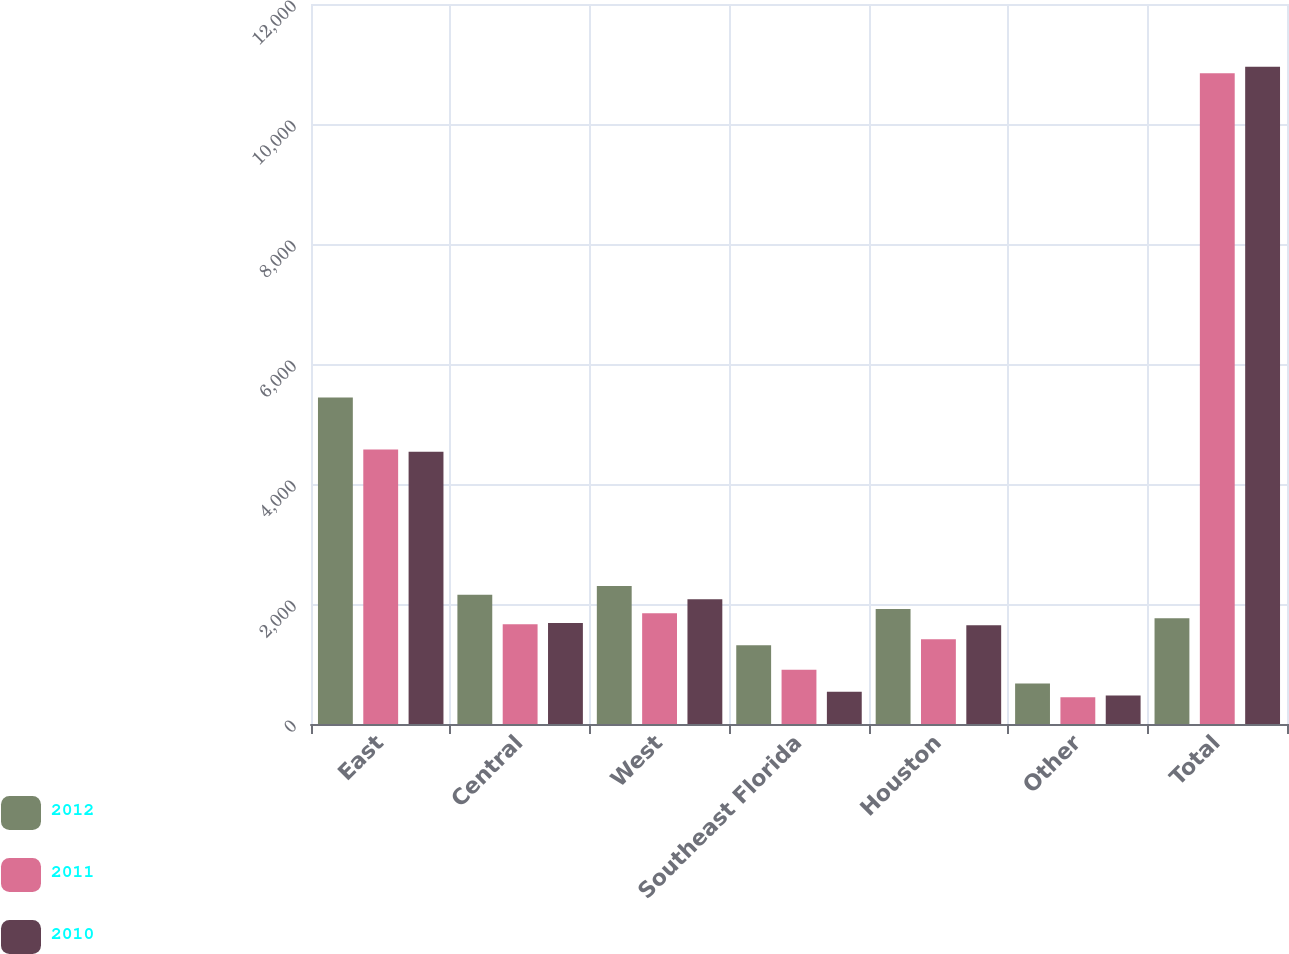<chart> <loc_0><loc_0><loc_500><loc_500><stacked_bar_chart><ecel><fcel>East<fcel>Central<fcel>West<fcel>Southeast Florida<fcel>Houston<fcel>Other<fcel>Total<nl><fcel>2012<fcel>5440<fcel>2154<fcel>2301<fcel>1314<fcel>1917<fcel>676<fcel>1764<nl><fcel>2011<fcel>4576<fcel>1661<fcel>1846<fcel>904<fcel>1411<fcel>447<fcel>10845<nl><fcel>2010<fcel>4539<fcel>1682<fcel>2079<fcel>536<fcel>1645<fcel>474<fcel>10955<nl></chart> 